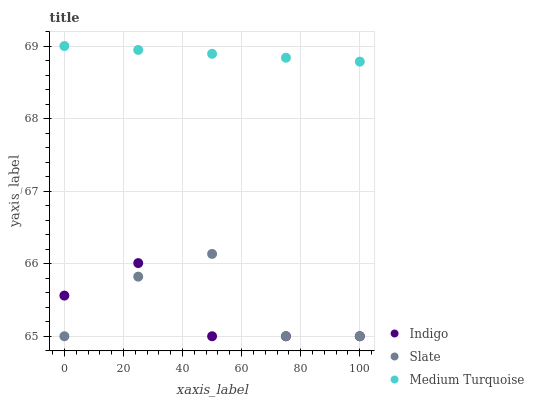Does Indigo have the minimum area under the curve?
Answer yes or no. Yes. Does Medium Turquoise have the maximum area under the curve?
Answer yes or no. Yes. Does Medium Turquoise have the minimum area under the curve?
Answer yes or no. No. Does Indigo have the maximum area under the curve?
Answer yes or no. No. Is Medium Turquoise the smoothest?
Answer yes or no. Yes. Is Slate the roughest?
Answer yes or no. Yes. Is Indigo the smoothest?
Answer yes or no. No. Is Indigo the roughest?
Answer yes or no. No. Does Slate have the lowest value?
Answer yes or no. Yes. Does Medium Turquoise have the lowest value?
Answer yes or no. No. Does Medium Turquoise have the highest value?
Answer yes or no. Yes. Does Indigo have the highest value?
Answer yes or no. No. Is Slate less than Medium Turquoise?
Answer yes or no. Yes. Is Medium Turquoise greater than Indigo?
Answer yes or no. Yes. Does Indigo intersect Slate?
Answer yes or no. Yes. Is Indigo less than Slate?
Answer yes or no. No. Is Indigo greater than Slate?
Answer yes or no. No. Does Slate intersect Medium Turquoise?
Answer yes or no. No. 